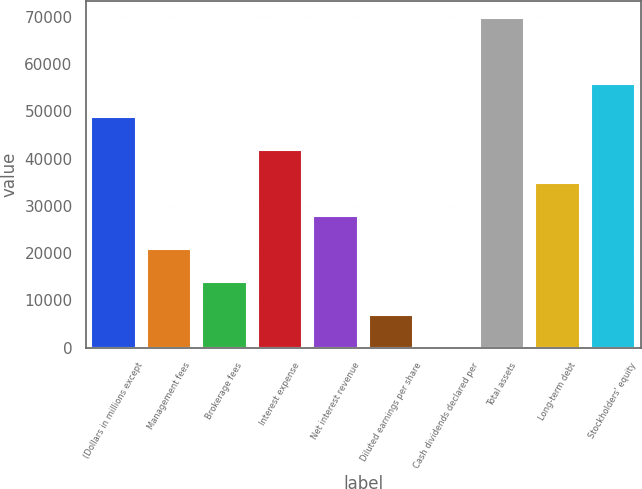Convert chart to OTSL. <chart><loc_0><loc_0><loc_500><loc_500><bar_chart><fcel>(Dollars in millions except<fcel>Management fees<fcel>Brokerage fees<fcel>Interest expense<fcel>Net interest revenue<fcel>Diluted earnings per share<fcel>Cash dividends declared per<fcel>Total assets<fcel>Long-term debt<fcel>Stockholders' equity<nl><fcel>48895.1<fcel>20955.3<fcel>13970.3<fcel>41910.2<fcel>27940.2<fcel>6985.37<fcel>0.41<fcel>69850<fcel>34925.2<fcel>55880.1<nl></chart> 